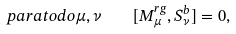Convert formula to latex. <formula><loc_0><loc_0><loc_500><loc_500>\ p a r a t o d o \mu , \nu \quad [ M _ { \mu } ^ { r g } , S _ { \nu } ^ { b } ] = 0 ,</formula> 